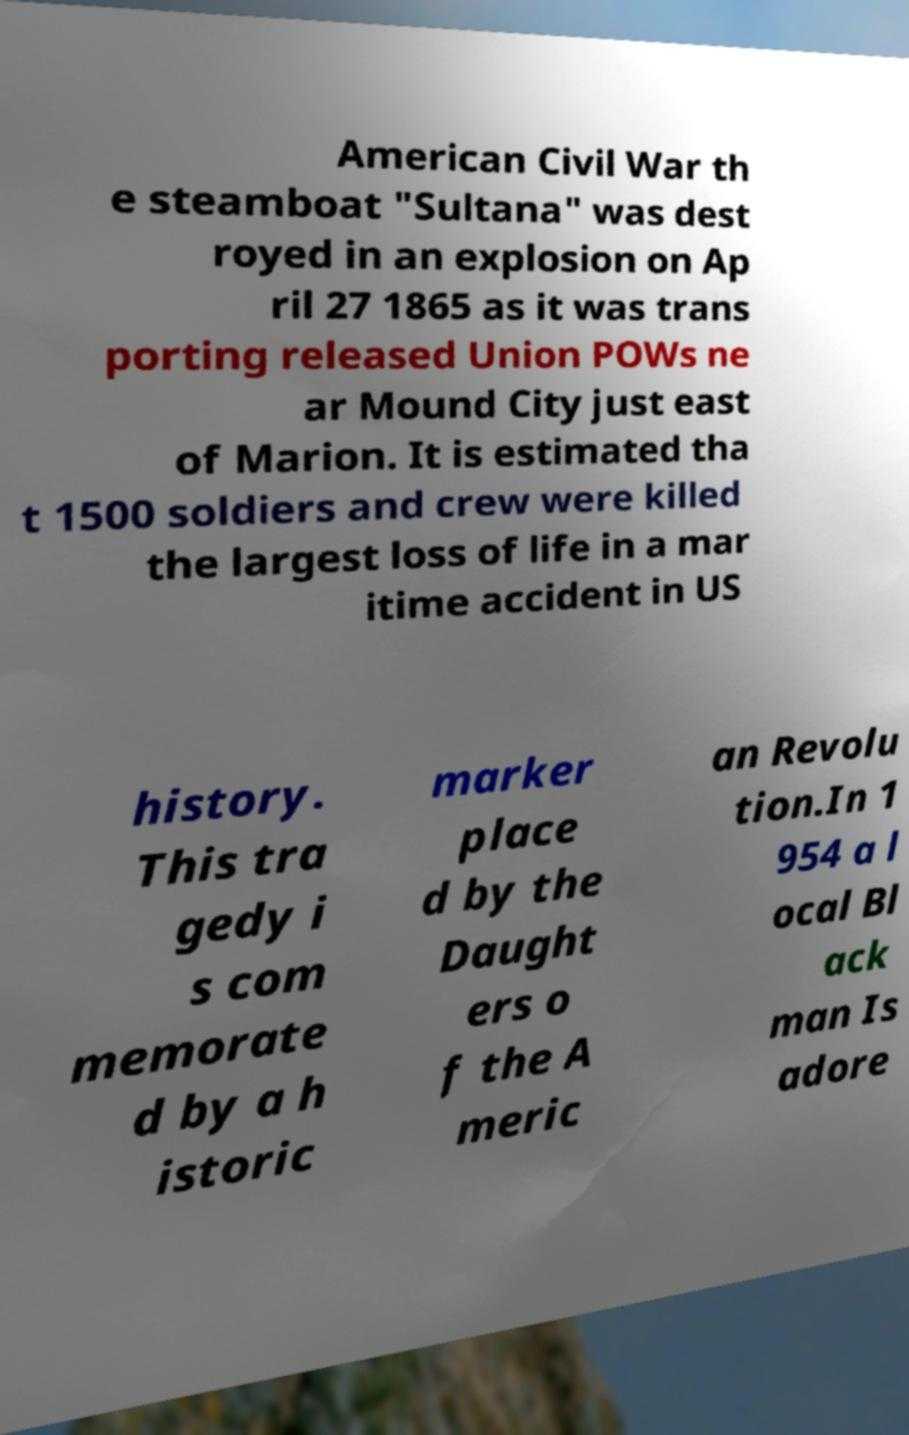Please identify and transcribe the text found in this image. American Civil War th e steamboat "Sultana" was dest royed in an explosion on Ap ril 27 1865 as it was trans porting released Union POWs ne ar Mound City just east of Marion. It is estimated tha t 1500 soldiers and crew were killed the largest loss of life in a mar itime accident in US history. This tra gedy i s com memorate d by a h istoric marker place d by the Daught ers o f the A meric an Revolu tion.In 1 954 a l ocal Bl ack man Is adore 